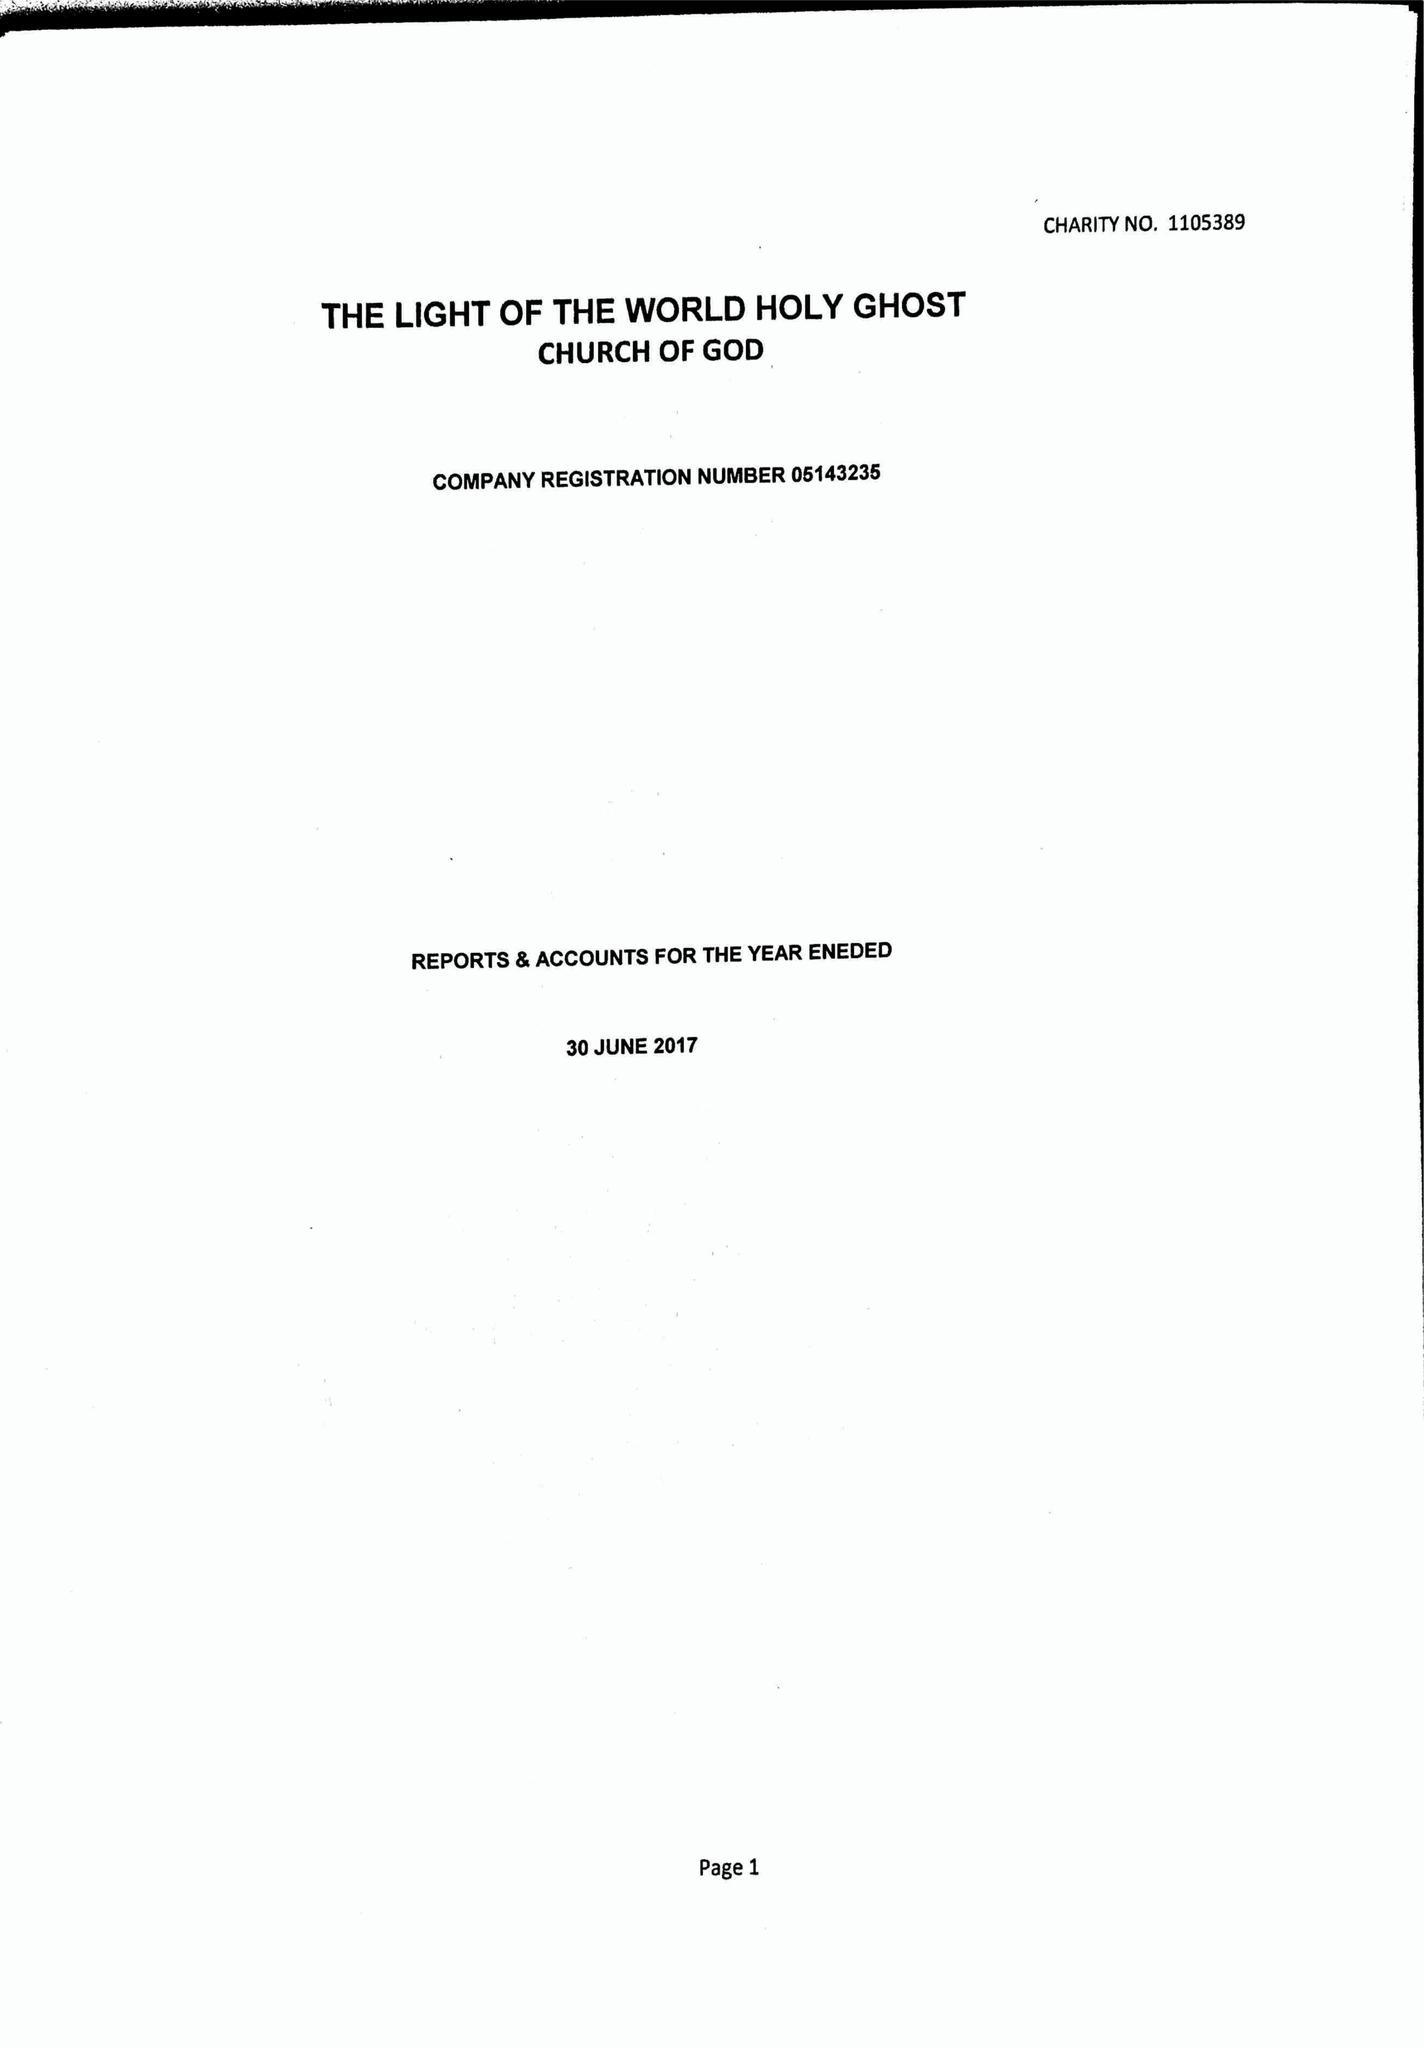What is the value for the income_annually_in_british_pounds?
Answer the question using a single word or phrase. 107716.00 